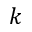Convert formula to latex. <formula><loc_0><loc_0><loc_500><loc_500>k</formula> 